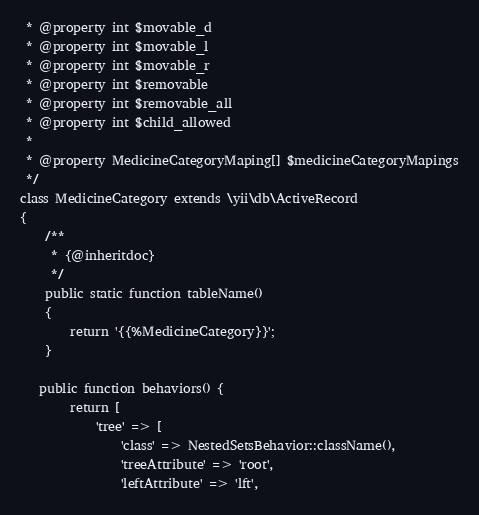<code> <loc_0><loc_0><loc_500><loc_500><_PHP_> * @property int $movable_d
 * @property int $movable_l
 * @property int $movable_r
 * @property int $removable
 * @property int $removable_all
 * @property int $child_allowed
 *
 * @property MedicineCategoryMaping[] $medicineCategoryMapings
 */
class MedicineCategory extends \yii\db\ActiveRecord
{
    /**
     * {@inheritdoc}
     */
    public static function tableName()
    {
        return '{{%MedicineCategory}}';
    }

   public function behaviors() {
        return [
            'tree' => [
                'class' => NestedSetsBehavior::className(),
                'treeAttribute' => 'root',
                'leftAttribute' => 'lft',</code> 